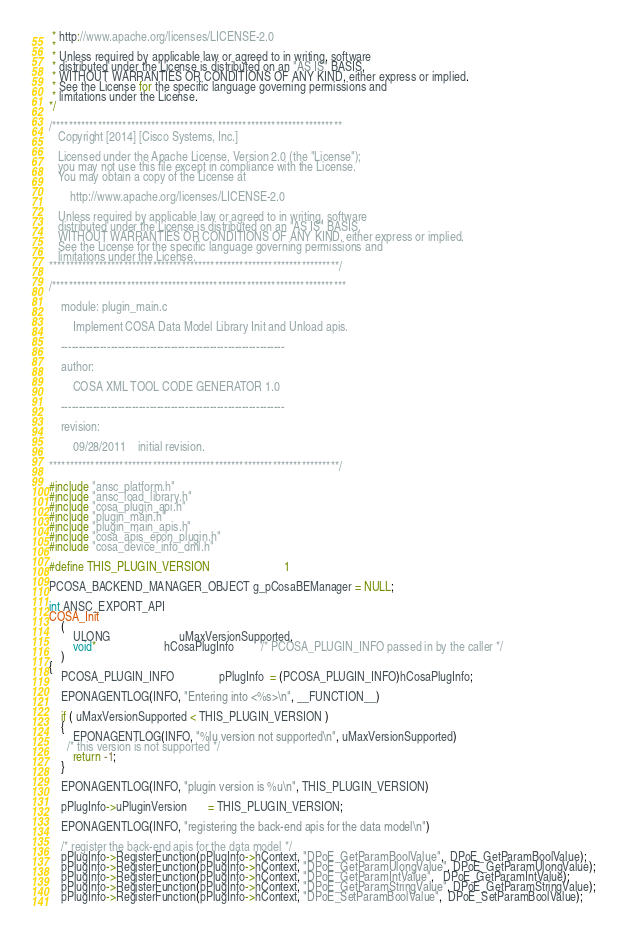Convert code to text. <code><loc_0><loc_0><loc_500><loc_500><_C_> * http://www.apache.org/licenses/LICENSE-2.0
 *
 * Unless required by applicable law or agreed to in writing, software
 * distributed under the License is distributed on an "AS IS" BASIS,
 * WITHOUT WARRANTIES OR CONDITIONS OF ANY KIND, either express or implied.
 * See the License for the specific language governing permissions and
 * limitations under the License.
*/

/**********************************************************************
   Copyright [2014] [Cisco Systems, Inc.]

   Licensed under the Apache License, Version 2.0 (the "License");
   you may not use this file except in compliance with the License.
   You may obtain a copy of the License at

       http://www.apache.org/licenses/LICENSE-2.0

   Unless required by applicable law or agreed to in writing, software
   distributed under the License is distributed on an "AS IS" BASIS,
   WITHOUT WARRANTIES OR CONDITIONS OF ANY KIND, either express or implied.
   See the License for the specific language governing permissions and
   limitations under the License.
**********************************************************************/

/***********************************************************************

    module: plugin_main.c

        Implement COSA Data Model Library Init and Unload apis.

    ---------------------------------------------------------------

    author:

        COSA XML TOOL CODE GENERATOR 1.0

    ---------------------------------------------------------------

    revision:

        09/28/2011    initial revision.

**********************************************************************/

#include "ansc_platform.h"
#include "ansc_load_library.h"
#include "cosa_plugin_api.h"
#include "plugin_main.h"
#include "plugin_main_apis.h"
#include "cosa_apis_epon_plugin.h"
#include "cosa_device_info_dml.h"

#define THIS_PLUGIN_VERSION                         1

PCOSA_BACKEND_MANAGER_OBJECT g_pCosaBEManager = NULL;

int ANSC_EXPORT_API
COSA_Init
    (
        ULONG                       uMaxVersionSupported,
        void*                       hCosaPlugInfo         /* PCOSA_PLUGIN_INFO passed in by the caller */
    )
{
    PCOSA_PLUGIN_INFO               pPlugInfo  = (PCOSA_PLUGIN_INFO)hCosaPlugInfo;

    EPONAGENTLOG(INFO, "Entering into <%s>\n", __FUNCTION__)

    if ( uMaxVersionSupported < THIS_PLUGIN_VERSION )
    {
        EPONAGENTLOG(INFO, "%lu version not supported\n", uMaxVersionSupported)
      /* this version is not supported */
        return -1;
    }

    EPONAGENTLOG(INFO, "plugin version is %u\n", THIS_PLUGIN_VERSION)

    pPlugInfo->uPluginVersion       = THIS_PLUGIN_VERSION;

    EPONAGENTLOG(INFO, "registering the back-end apis for the data model\n")

    /* register the back-end apis for the data model */
    pPlugInfo->RegisterFunction(pPlugInfo->hContext, "DPoE_GetParamBoolValue",  DPoE_GetParamBoolValue);
    pPlugInfo->RegisterFunction(pPlugInfo->hContext, "DPoE_GetParamUlongValue", DPoE_GetParamUlongValue);
    pPlugInfo->RegisterFunction(pPlugInfo->hContext, "DPoE_GetParamIntValue",   DPoE_GetParamIntValue);
    pPlugInfo->RegisterFunction(pPlugInfo->hContext, "DPoE_GetParamStringValue", DPoE_GetParamStringValue);
    pPlugInfo->RegisterFunction(pPlugInfo->hContext, "DPoE_SetParamBoolValue",  DPoE_SetParamBoolValue);</code> 